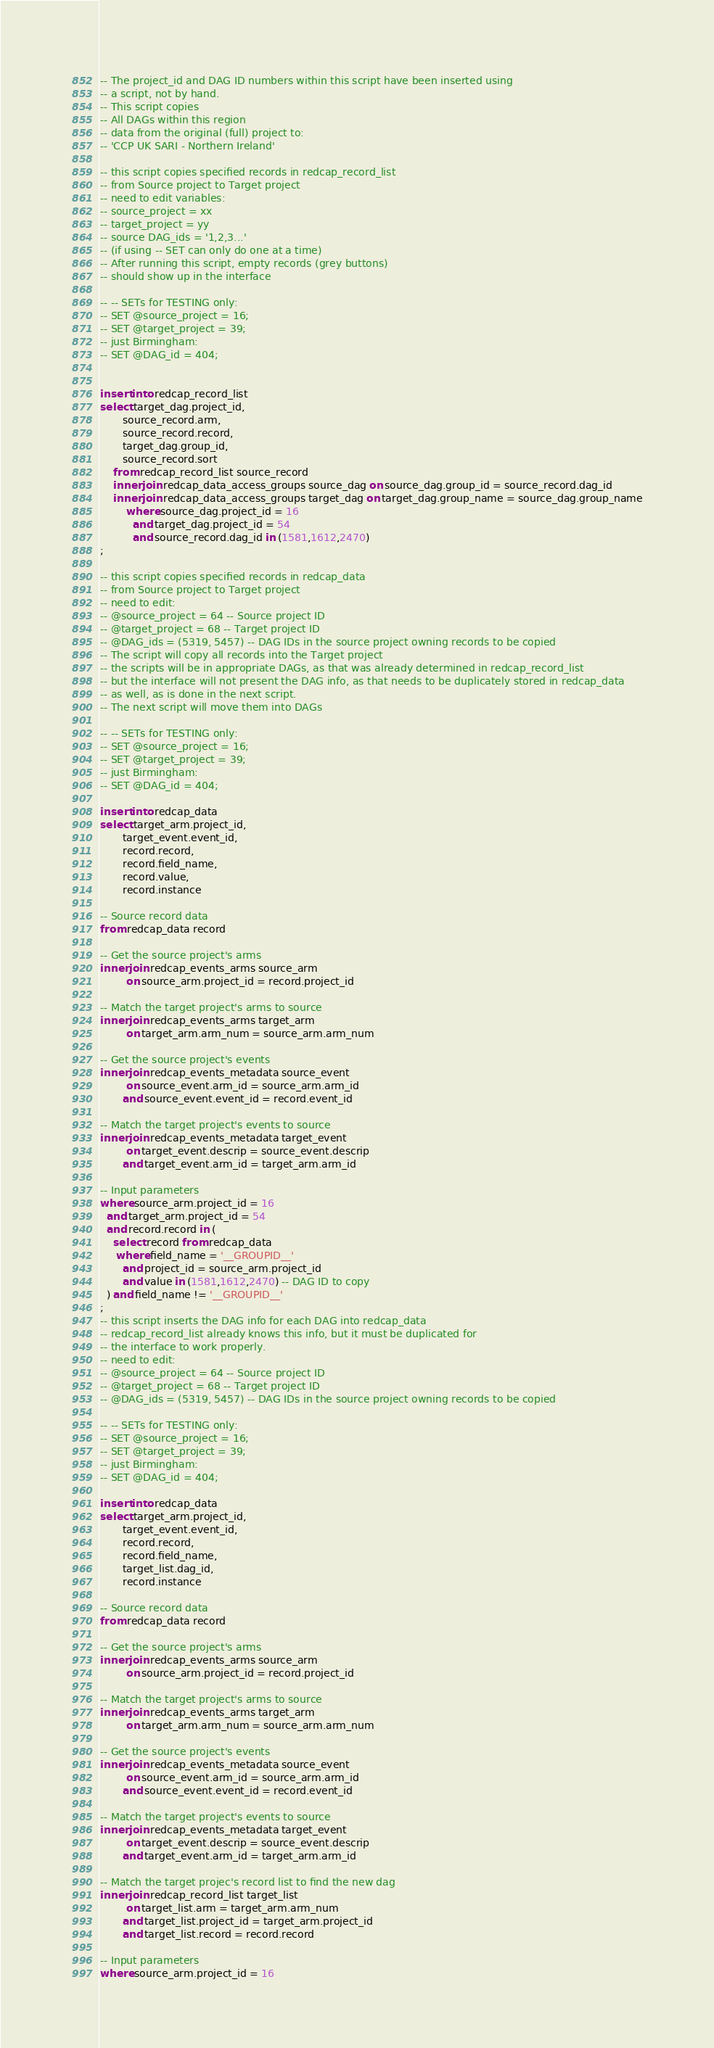Convert code to text. <code><loc_0><loc_0><loc_500><loc_500><_SQL_>-- The project_id and DAG ID numbers within this script have been inserted using
-- a script, not by hand.
-- This script copies
-- All DAGs within this region
-- data from the original (full) project to:
-- 'CCP UK SARI - Northern Ireland'

-- this script copies specified records in redcap_record_list
-- from Source project to Target project
-- need to edit variables:
-- source_project = xx
-- target_project = yy
-- source DAG_ids = '1,2,3...'
-- (if using -- SET can only do one at a time)
-- After running this script, empty records (grey buttons)
-- should show up in the interface

-- -- SETs for TESTING only:
-- SET @source_project = 16;
-- SET @target_project = 39;
-- just Birmingham:
-- SET @DAG_id = 404;


insert into redcap_record_list
select target_dag.project_id,
       source_record.arm,
       source_record.record,
       target_dag.group_id,
       source_record.sort
    from redcap_record_list source_record
    inner join redcap_data_access_groups source_dag on source_dag.group_id = source_record.dag_id
    inner join redcap_data_access_groups target_dag on target_dag.group_name = source_dag.group_name
        where source_dag.project_id = 16
          and target_dag.project_id = 54
          and source_record.dag_id in (1581,1612,2470)
;

-- this script copies specified records in redcap_data
-- from Source project to Target project
-- need to edit:
-- @source_project = 64 -- Source project ID
-- @target_project = 68 -- Target project ID
-- @DAG_ids = (5319, 5457) -- DAG IDs in the source project owning records to be copied
-- The script will copy all records into the Target project
-- the scripts will be in appropriate DAGs, as that was already determined in redcap_record_list
-- but the interface will not present the DAG info, as that needs to be duplicately stored in redcap_data
-- as well, as is done in the next script.
-- The next script will move them into DAGs

-- -- SETs for TESTING only:
-- SET @source_project = 16;
-- SET @target_project = 39;
-- just Birmingham:
-- SET @DAG_id = 404;

insert into redcap_data
select target_arm.project_id,
       target_event.event_id,
       record.record,
       record.field_name,
       record.value,
       record.instance

-- Source record data
from redcap_data record

-- Get the source project's arms
inner join redcap_events_arms source_arm
        on source_arm.project_id = record.project_id

-- Match the target project's arms to source
inner join redcap_events_arms target_arm
        on target_arm.arm_num = source_arm.arm_num

-- Get the source project's events
inner join redcap_events_metadata source_event
        on source_event.arm_id = source_arm.arm_id
       and source_event.event_id = record.event_id

-- Match the target project's events to source
inner join redcap_events_metadata target_event
        on target_event.descrip = source_event.descrip
       and target_event.arm_id = target_arm.arm_id

-- Input parameters
where source_arm.project_id = 16
  and target_arm.project_id = 54
  and record.record in (
    select record from redcap_data
     where field_name = '__GROUPID__'
       and project_id = source_arm.project_id
       and value in (1581,1612,2470) -- DAG ID to copy
  ) and field_name != '__GROUPID__'
;
-- this script inserts the DAG info for each DAG into redcap_data
-- redcap_record_list already knows this info, but it must be duplicated for
-- the interface to work properly.
-- need to edit:
-- @source_project = 64 -- Source project ID
-- @target_project = 68 -- Target project ID
-- @DAG_ids = (5319, 5457) -- DAG IDs in the source project owning records to be copied

-- -- SETs for TESTING only:
-- SET @source_project = 16;
-- SET @target_project = 39;
-- just Birmingham:
-- SET @DAG_id = 404;

insert into redcap_data
select target_arm.project_id,
       target_event.event_id,
       record.record,
       record.field_name,
       target_list.dag_id,
       record.instance

-- Source record data
from redcap_data record

-- Get the source project's arms
inner join redcap_events_arms source_arm
        on source_arm.project_id = record.project_id

-- Match the target project's arms to source
inner join redcap_events_arms target_arm
        on target_arm.arm_num = source_arm.arm_num

-- Get the source project's events
inner join redcap_events_metadata source_event
        on source_event.arm_id = source_arm.arm_id
       and source_event.event_id = record.event_id

-- Match the target project's events to source
inner join redcap_events_metadata target_event
        on target_event.descrip = source_event.descrip
       and target_event.arm_id = target_arm.arm_id

-- Match the target projec's record list to find the new dag
inner join redcap_record_list target_list
        on target_list.arm = target_arm.arm_num
       and target_list.project_id = target_arm.project_id
       and target_list.record = record.record

-- Input parameters
where source_arm.project_id = 16</code> 